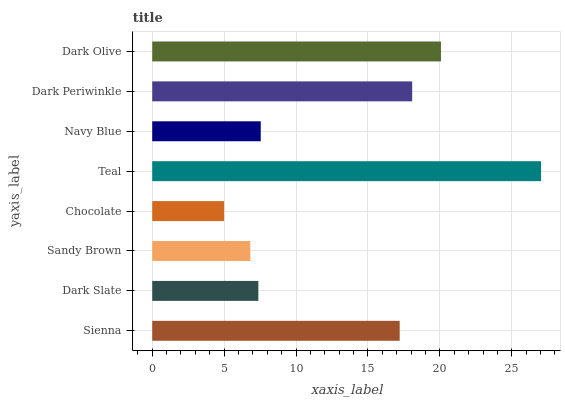Is Chocolate the minimum?
Answer yes or no. Yes. Is Teal the maximum?
Answer yes or no. Yes. Is Dark Slate the minimum?
Answer yes or no. No. Is Dark Slate the maximum?
Answer yes or no. No. Is Sienna greater than Dark Slate?
Answer yes or no. Yes. Is Dark Slate less than Sienna?
Answer yes or no. Yes. Is Dark Slate greater than Sienna?
Answer yes or no. No. Is Sienna less than Dark Slate?
Answer yes or no. No. Is Sienna the high median?
Answer yes or no. Yes. Is Navy Blue the low median?
Answer yes or no. Yes. Is Chocolate the high median?
Answer yes or no. No. Is Sienna the low median?
Answer yes or no. No. 